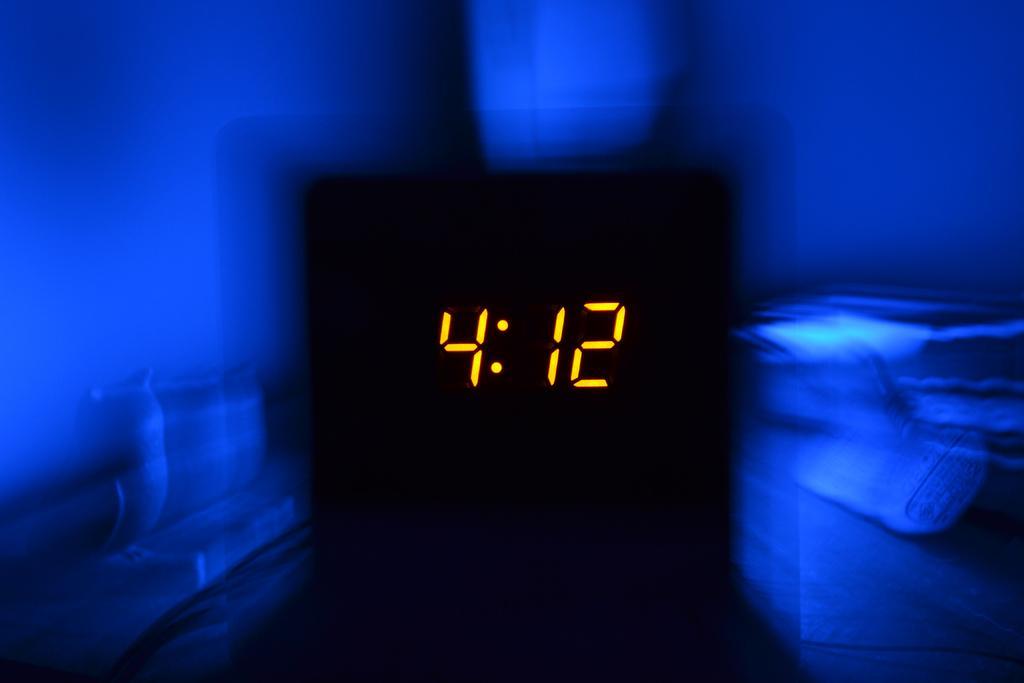Can you describe this image briefly? In this picture, we see the electronic device which is displaying the numbers. In the middle of the picture, it is black in color. In the background, it is blue in color. This picture is blurred in the background. 